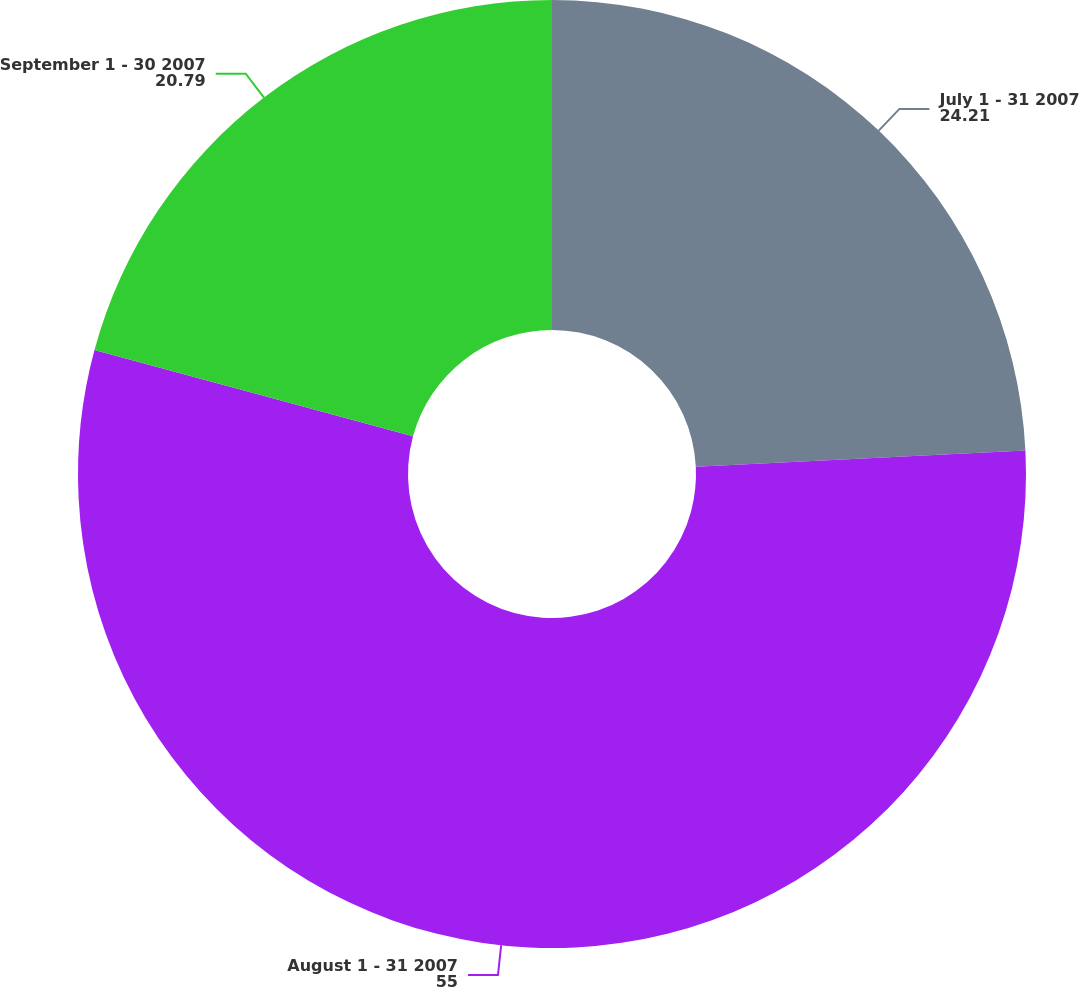Convert chart to OTSL. <chart><loc_0><loc_0><loc_500><loc_500><pie_chart><fcel>July 1 - 31 2007<fcel>August 1 - 31 2007<fcel>September 1 - 30 2007<nl><fcel>24.21%<fcel>55.0%<fcel>20.79%<nl></chart> 